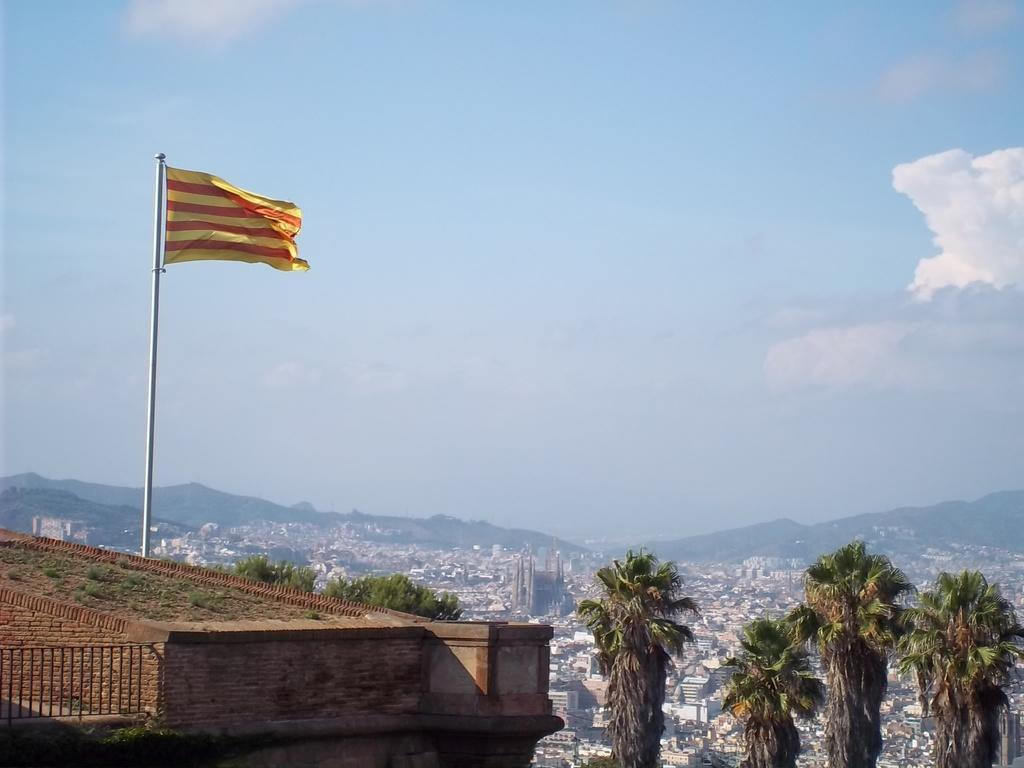In one or two sentences, can you explain what this image depicts? On the roof of a building there is grass and railing. Also there is a flag with a pole. Near to that there are trees. In the background there are buildings, hills and sky with clouds. 